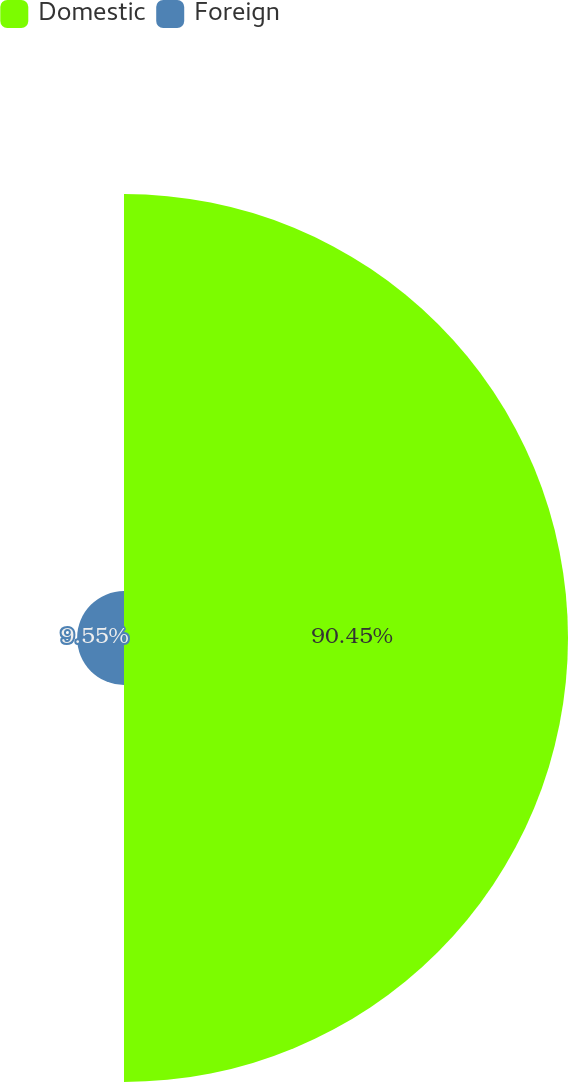<chart> <loc_0><loc_0><loc_500><loc_500><pie_chart><fcel>Domestic<fcel>Foreign<nl><fcel>90.45%<fcel>9.55%<nl></chart> 